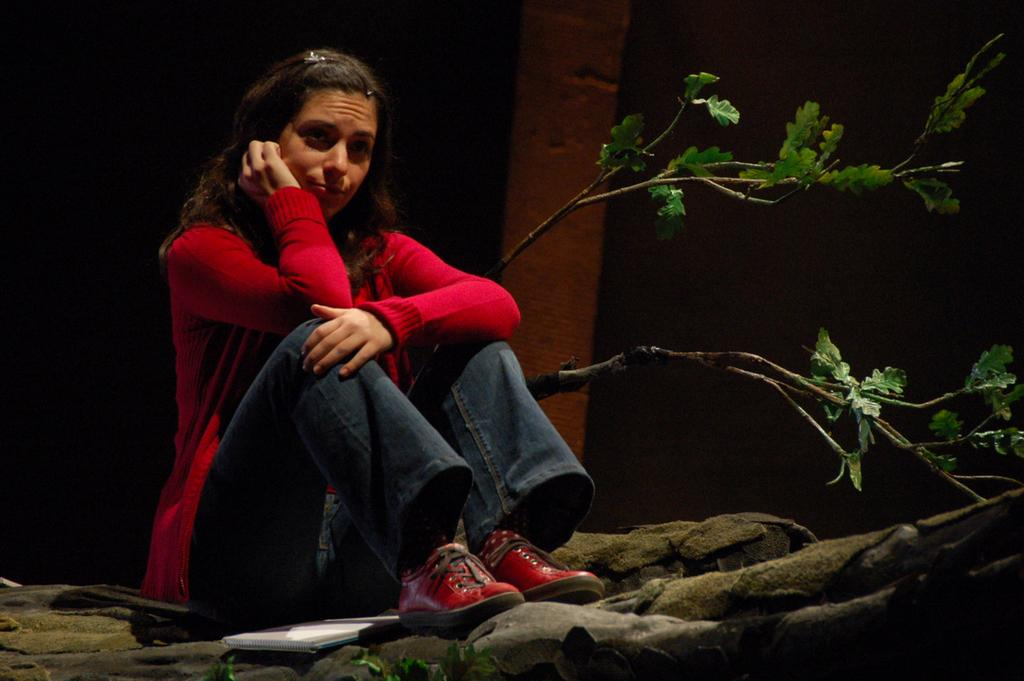Who is the main subject in the image? There is a woman in the image. What is the woman wearing? The woman is wearing a red jacket. What is the woman sitting on? The woman is sitting on a wooden trunk. What else can be seen on the wooden trunk? There is a book on the wooden trunk. What can be seen in the background of the image? There are branches with leaves visible in the background. What does the caption say about the woman in the image? There is no caption present in the image, so it is not possible to determine what it might say about the woman. 